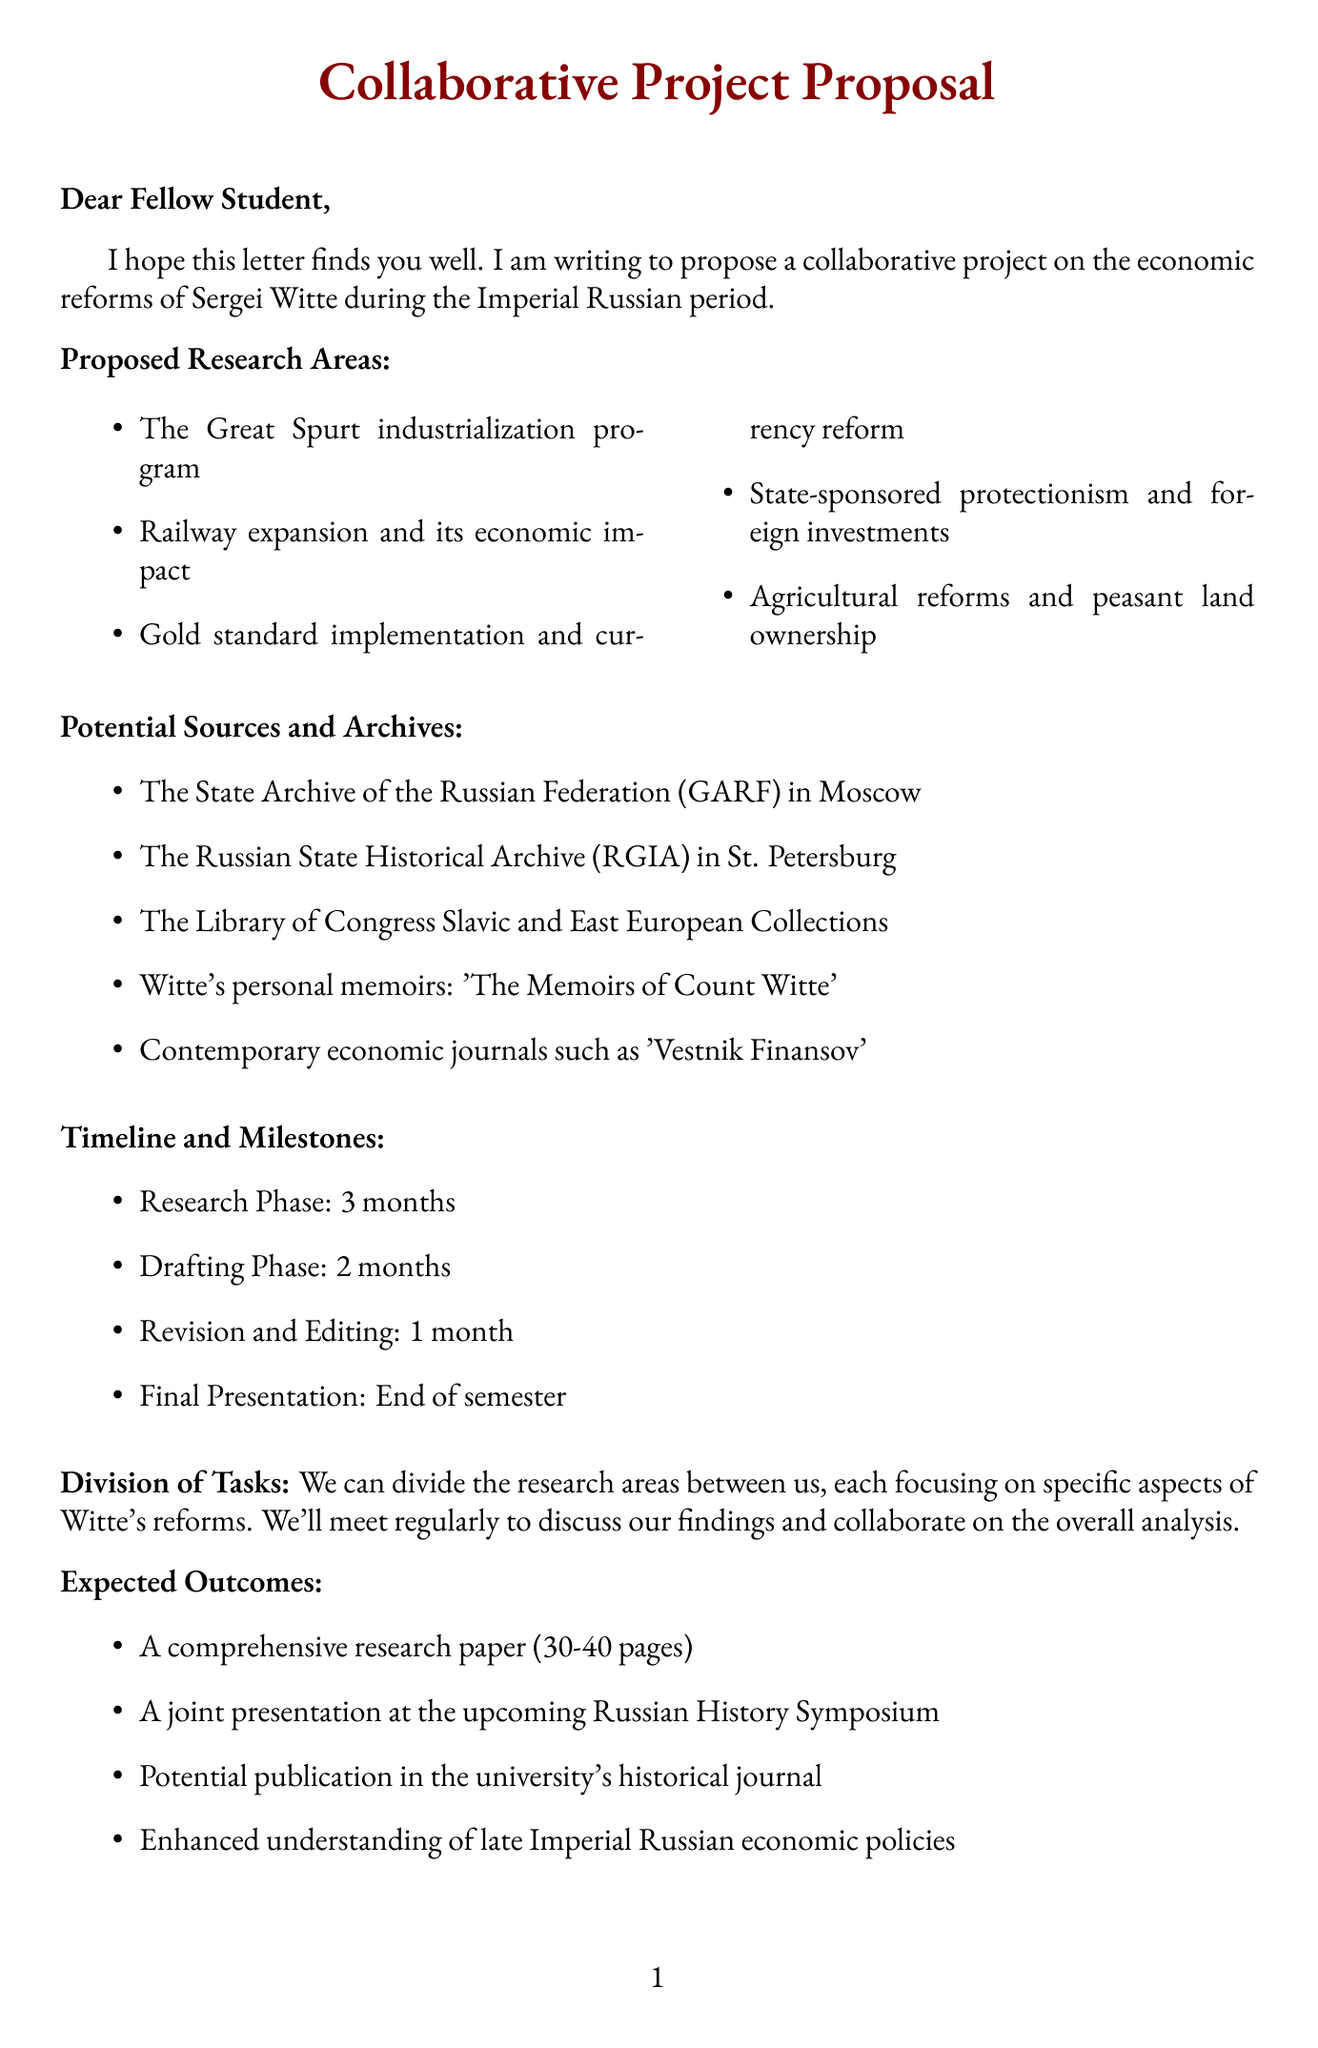what is the salutation of the letter? The salutation addresses the recipient of the letter, which is written at the beginning.
Answer: Dear Fellow Student, what are two proposed research areas mentioned? The document lists several areas of research, asking for specific examples.
Answer: The Great Spurt industrialization program; Railway expansion and its economic impact who is the main figure associated with the economic reforms discussed? The letter focuses on the economic reforms of a particular person during a historical period.
Answer: Sergei Witte how long is the research phase scheduled to last? The document outlines a timeline for the project, specifying the duration for each phase.
Answer: 3 months what are the expected outcomes of the project? The letter mentions several goals that the collaboration aims to achieve.
Answer: A comprehensive research paper (30-40 pages); A joint presentation at the upcoming Russian History Symposium what is one of the challenges mentioned in the document? The document lists obstacles that may affect the project, seeking a specific example.
Answer: Opposition from conservative nobility who succeeded Sergei Witte as Minister of Finance? The document includes a list of key figures involved with Witte, identifying those who followed him.
Answer: Vladimir Kokovtsov what is the total duration of the project outlined in the timeline? The letter provides a breakdown of phases, allowing for a calculation of the entire timeline.
Answer: 6 months (3 months + 2 months + 1 month) 